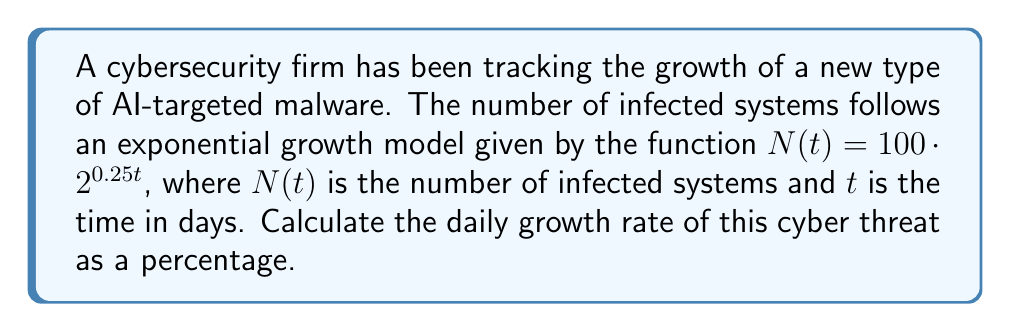Provide a solution to this math problem. To find the daily growth rate, we need to determine how much the number of infected systems increases each day, expressed as a percentage.

1) In an exponential function of the form $f(t) = a \cdot b^{rt}$, the growth rate per unit of time is given by $(b^r - 1) \cdot 100\%$.

2) In our case, $N(t) = 100 \cdot 2^{0.25t}$, so $b = 2$ and $r = 0.25$.

3) Let's substitute these values:

   Daily growth rate $= (2^{0.25} - 1) \cdot 100\%$

4) Calculate $2^{0.25}$:
   
   $2^{0.25} \approx 1.1892$ (rounded to 4 decimal places)

5) Subtract 1 and multiply by 100%:

   $(1.1892 - 1) \cdot 100\% = 0.1892 \cdot 100\% = 18.92\%$

Thus, the daily growth rate of this cyber threat is approximately 18.92%.
Answer: 18.92% 